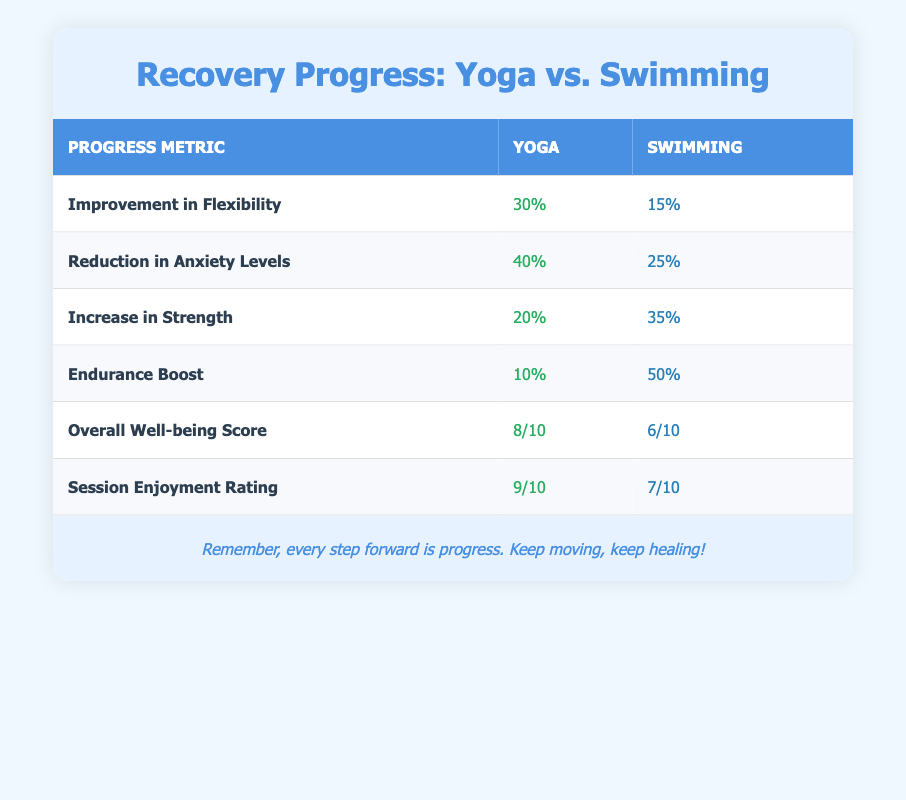What is the percentage improvement in flexibility for yoga? The table lists ‘Improvement in Flexibility’ under the yoga column as 30%. Therefore, the percentage improvement in flexibility for yoga is directly found from the table.
Answer: 30% How much did swimming reduce anxiety levels? The table shows that ‘Reduction in Anxiety Levels’ for swimming is 25%. This information can be found in the respective row and under the swimming column.
Answer: 25% Which activity shows greater improvement in strength, yoga or swimming? According to the table, the ‘Increase in Strength’ for yoga is 20%, while for swimming it is 35%. Therefore, swimming shows greater improvement.
Answer: Swimming What is the difference in the overall well-being scores between yoga and swimming? The ‘Overall Well-being Score’ for yoga is 8/10 and for swimming is 6/10. To find the difference, subtract 6 from 8, which equals 2.
Answer: 2 Is the enjoyment rating higher for yoga than for swimming? The enjoyment rating for yoga is 9/10, while swimming's rating is 7/10. Since 9/10 is greater than 7/10, the enjoyment rating is higher for yoga.
Answer: Yes What is the average reduction in anxiety levels for both activities? The reduction in anxiety levels for yoga is 40% and for swimming is 25%. To find the average: (40% + 25%) / 2 = 65% / 2 = 32.5%.
Answer: 32.5% Which activity has a higher endurance boost percentage? The table shows ‘Endurance Boost’ as 10% for yoga and 50% for swimming. Therefore, swimming has a higher percentage for endurance boost.
Answer: Swimming What percentage of improvement in flexibility does swimming show compared to yoga? Swimming's improvement in flexibility is 15%, while yoga's is 30%. Since 15% is lower than 30%, swimming shows less improvement in flexibility compared to yoga.
Answer: 15% If you wanted to improve flexibility and reduce anxiety, which activity would you prioritize? Yoga shows an improvement in flexibility at 30% and a reduction in anxiety levels at 40%. Swimming shows lower improvement in flexibility at 15% and lower reduction in anxiety at 25%. Therefore, prioritizing yoga would be beneficial to both metrics.
Answer: Yoga 